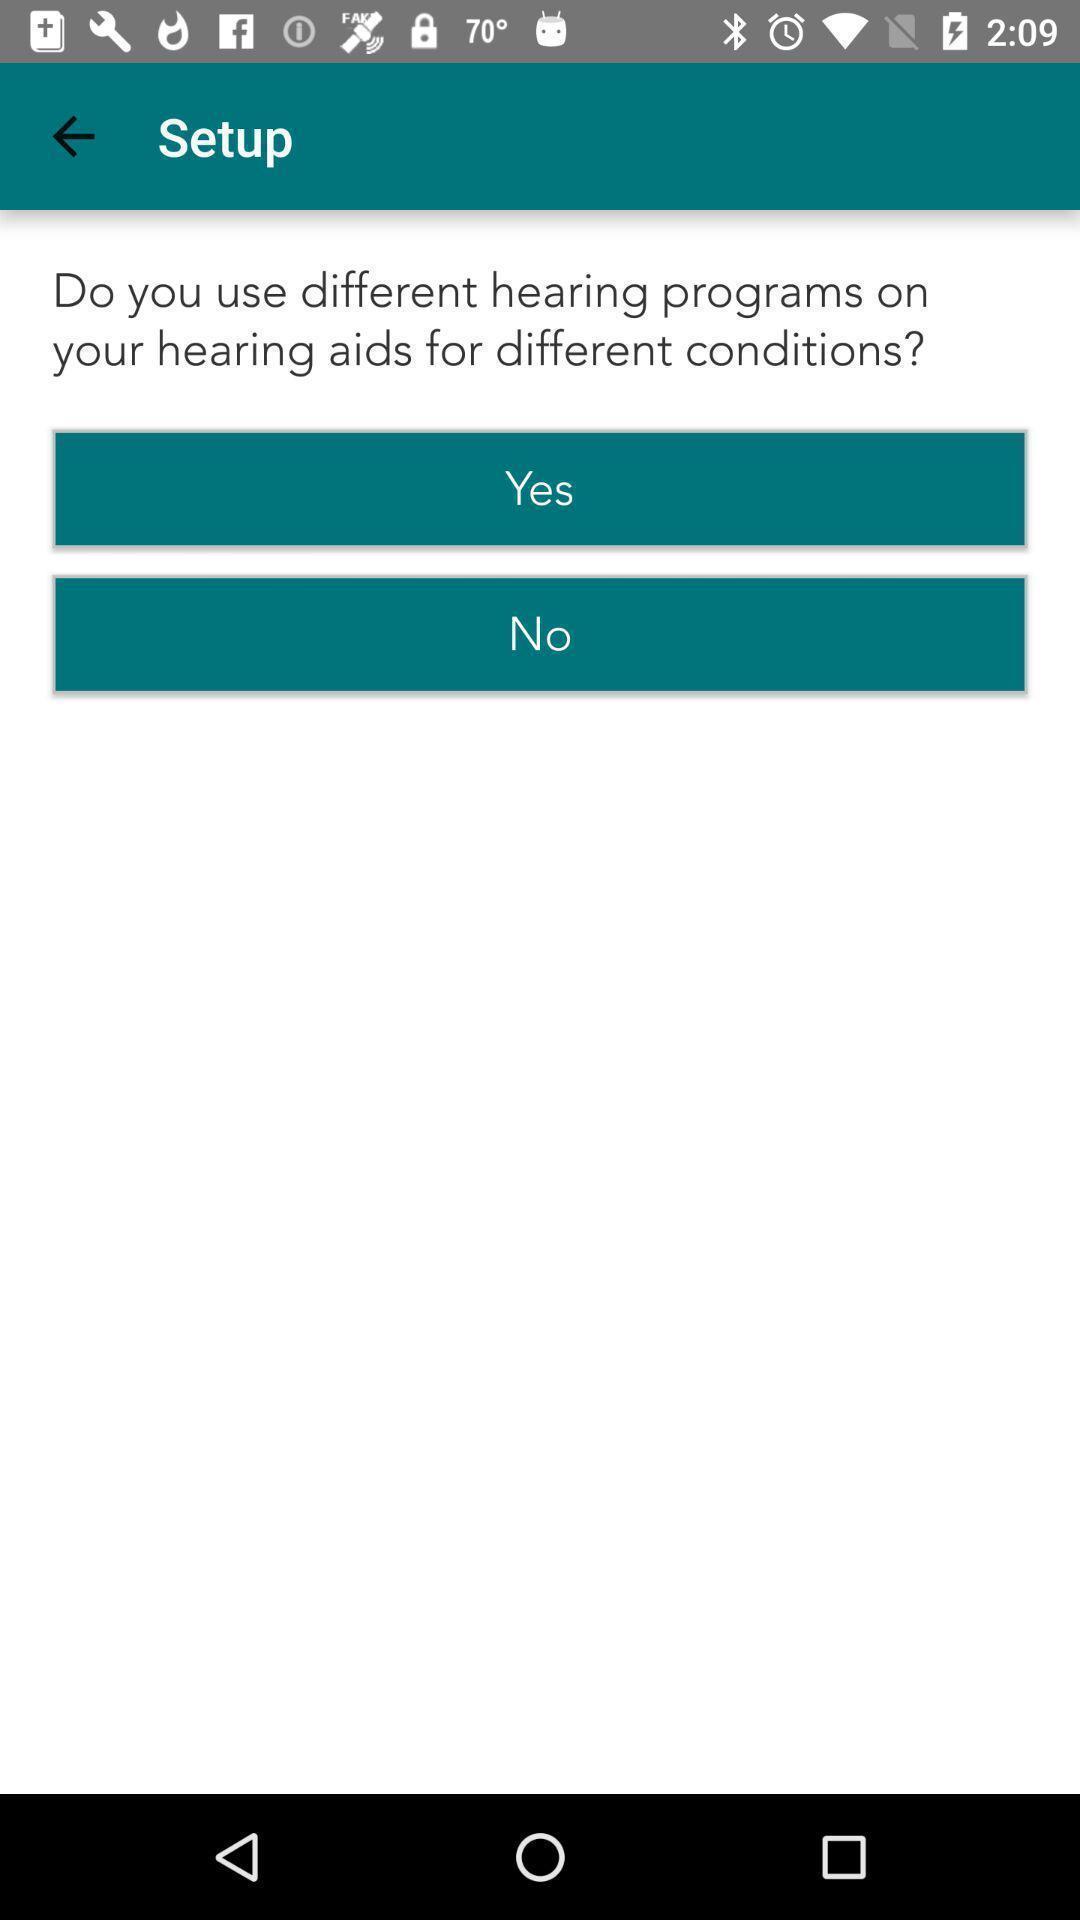Describe the key features of this screenshot. Setup page of a hearing care app. 